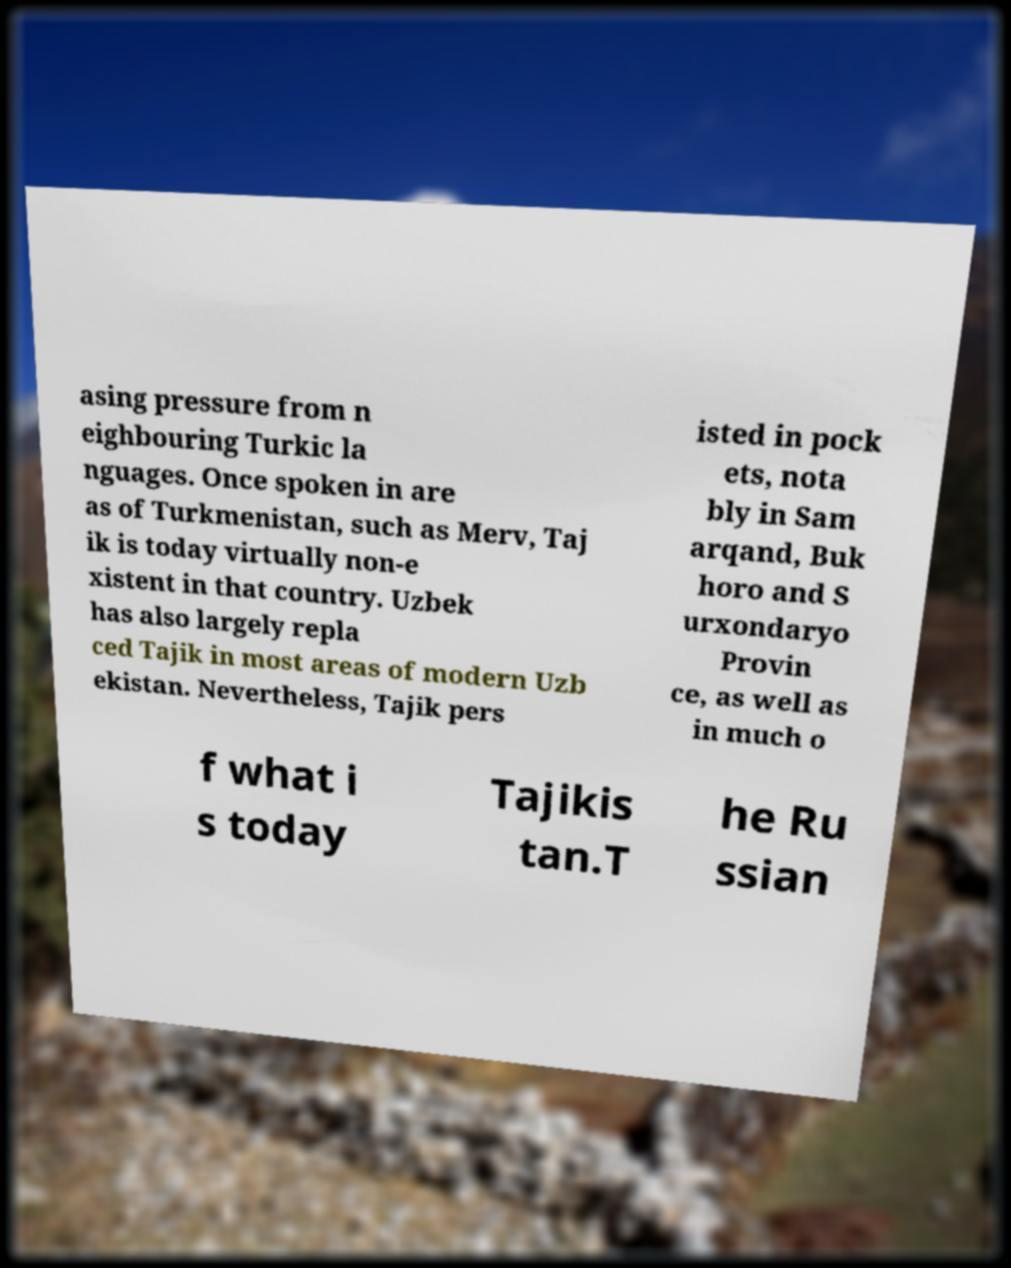Could you extract and type out the text from this image? asing pressure from n eighbouring Turkic la nguages. Once spoken in are as of Turkmenistan, such as Merv, Taj ik is today virtually non-e xistent in that country. Uzbek has also largely repla ced Tajik in most areas of modern Uzb ekistan. Nevertheless, Tajik pers isted in pock ets, nota bly in Sam arqand, Buk horo and S urxondaryo Provin ce, as well as in much o f what i s today Tajikis tan.T he Ru ssian 